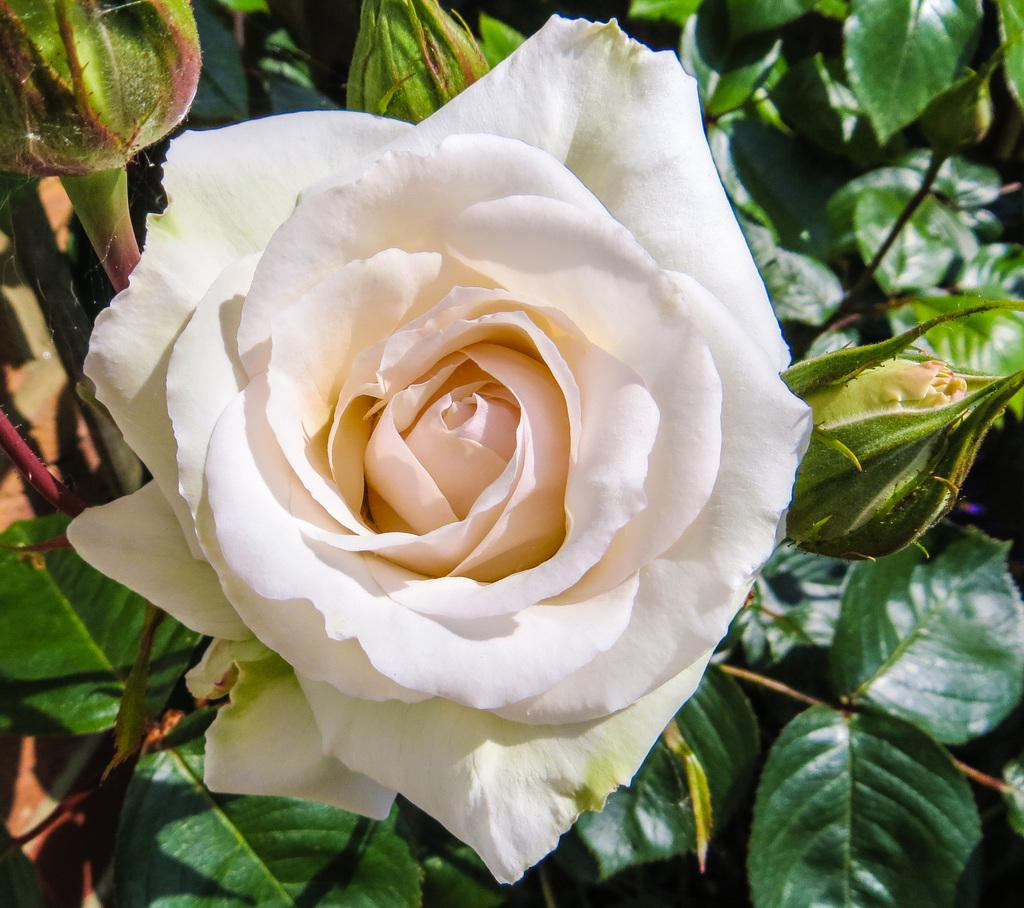What type of flower is in the image? There is a rose flower in the image. What is the color of the rose flower? The rose flower is white in color. Are there any unopened parts of the flower in the image? Yes, there are flower buds in the image. What else can be seen in the image besides the flower and buds? There are leaves in the image. What is the color of the leaves? The leaves are green in color. How many screws can be seen holding the rose flower together in the image? There are no screws present in the image; it is a natural rose flower. 